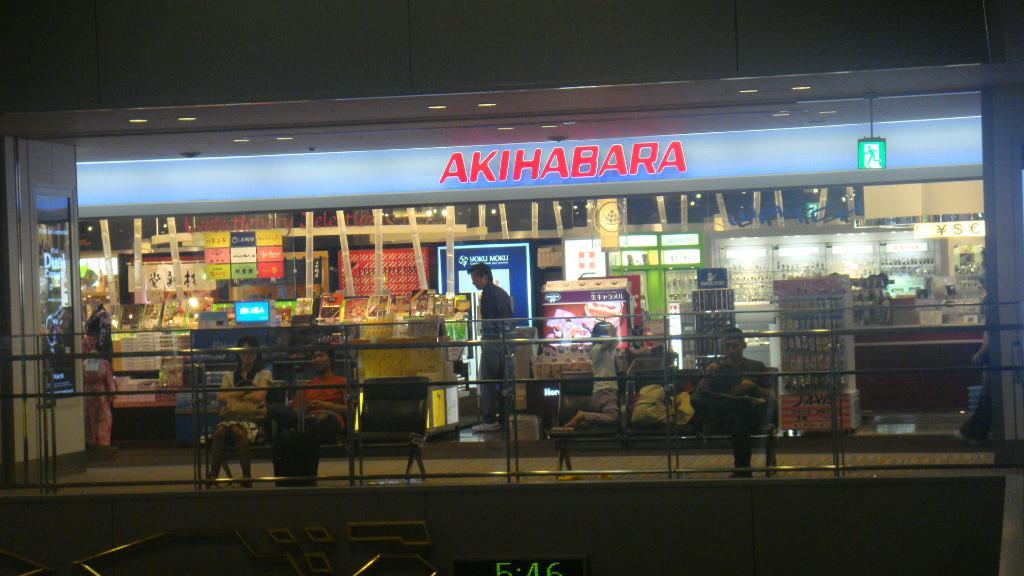Where is this shop located?
Offer a very short reply. Akihabara. 